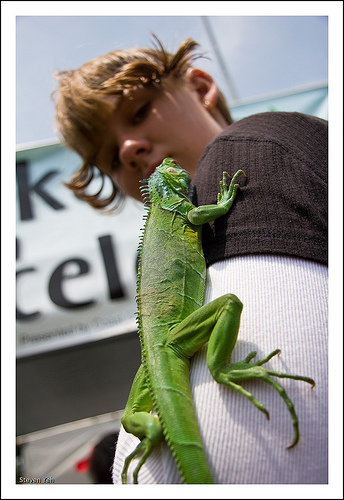<image>
Is the lizard under the boy? Yes. The lizard is positioned underneath the boy, with the boy above it in the vertical space. Is there a sign behind the lizard? Yes. From this viewpoint, the sign is positioned behind the lizard, with the lizard partially or fully occluding the sign. 